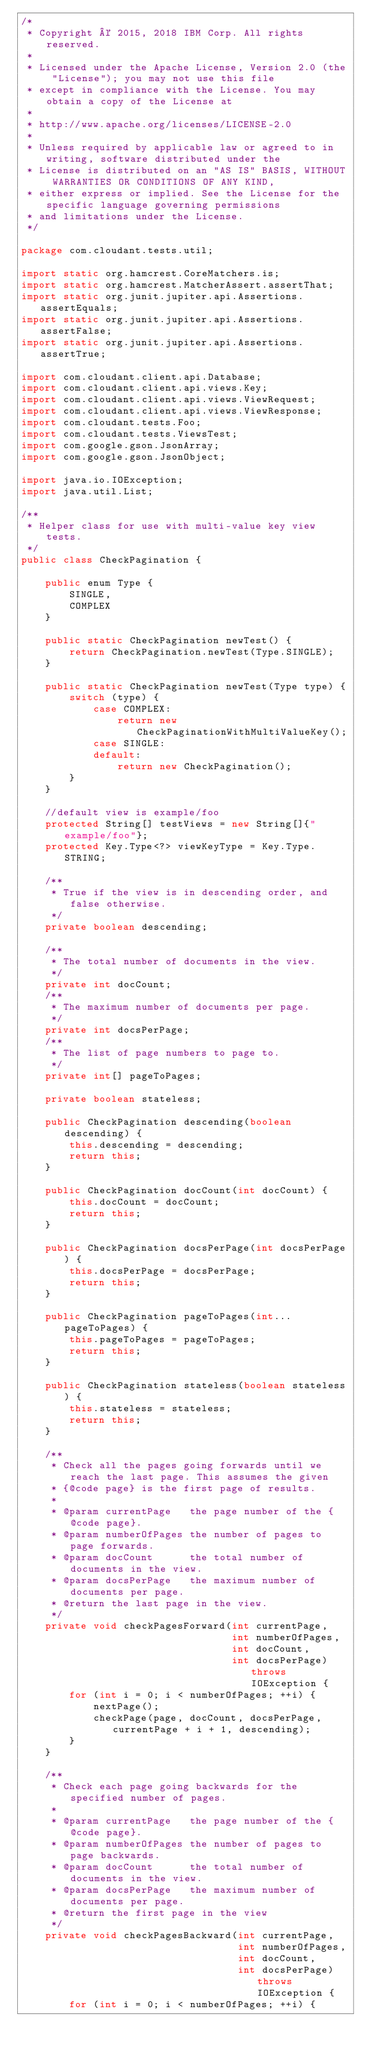<code> <loc_0><loc_0><loc_500><loc_500><_Java_>/*
 * Copyright © 2015, 2018 IBM Corp. All rights reserved.
 *
 * Licensed under the Apache License, Version 2.0 (the "License"); you may not use this file
 * except in compliance with the License. You may obtain a copy of the License at
 *
 * http://www.apache.org/licenses/LICENSE-2.0
 *
 * Unless required by applicable law or agreed to in writing, software distributed under the
 * License is distributed on an "AS IS" BASIS, WITHOUT WARRANTIES OR CONDITIONS OF ANY KIND,
 * either express or implied. See the License for the specific language governing permissions
 * and limitations under the License.
 */

package com.cloudant.tests.util;

import static org.hamcrest.CoreMatchers.is;
import static org.hamcrest.MatcherAssert.assertThat;
import static org.junit.jupiter.api.Assertions.assertEquals;
import static org.junit.jupiter.api.Assertions.assertFalse;
import static org.junit.jupiter.api.Assertions.assertTrue;

import com.cloudant.client.api.Database;
import com.cloudant.client.api.views.Key;
import com.cloudant.client.api.views.ViewRequest;
import com.cloudant.client.api.views.ViewResponse;
import com.cloudant.tests.Foo;
import com.cloudant.tests.ViewsTest;
import com.google.gson.JsonArray;
import com.google.gson.JsonObject;

import java.io.IOException;
import java.util.List;

/**
 * Helper class for use with multi-value key view tests.
 */
public class CheckPagination {

    public enum Type {
        SINGLE,
        COMPLEX
    }

    public static CheckPagination newTest() {
        return CheckPagination.newTest(Type.SINGLE);
    }

    public static CheckPagination newTest(Type type) {
        switch (type) {
            case COMPLEX:
                return new CheckPaginationWithMultiValueKey();
            case SINGLE:
            default:
                return new CheckPagination();
        }
    }

    //default view is example/foo
    protected String[] testViews = new String[]{"example/foo"};
    protected Key.Type<?> viewKeyType = Key.Type.STRING;

    /**
     * True if the view is in descending order, and false otherwise.
     */
    private boolean descending;

    /**
     * The total number of documents in the view.
     */
    private int docCount;
    /**
     * The maximum number of documents per page.
     */
    private int docsPerPage;
    /**
     * The list of page numbers to page to.
     */
    private int[] pageToPages;

    private boolean stateless;

    public CheckPagination descending(boolean descending) {
        this.descending = descending;
        return this;
    }

    public CheckPagination docCount(int docCount) {
        this.docCount = docCount;
        return this;
    }

    public CheckPagination docsPerPage(int docsPerPage) {
        this.docsPerPage = docsPerPage;
        return this;
    }

    public CheckPagination pageToPages(int... pageToPages) {
        this.pageToPages = pageToPages;
        return this;
    }

    public CheckPagination stateless(boolean stateless) {
        this.stateless = stateless;
        return this;
    }

    /**
     * Check all the pages going forwards until we reach the last page. This assumes the given
     * {@code page} is the first page of results.
     *
     * @param currentPage   the page number of the {@code page}.
     * @param numberOfPages the number of pages to page forwards.
     * @param docCount      the total number of documents in the view.
     * @param docsPerPage   the maximum number of documents per page.
     * @return the last page in the view.
     */
    private void checkPagesForward(int currentPage,
                                   int numberOfPages,
                                   int docCount,
                                   int docsPerPage) throws IOException {
        for (int i = 0; i < numberOfPages; ++i) {
            nextPage();
            checkPage(page, docCount, docsPerPage, currentPage + i + 1, descending);
        }
    }

    /**
     * Check each page going backwards for the specified number of pages.
     *
     * @param currentPage   the page number of the {@code page}.
     * @param numberOfPages the number of pages to page backwards.
     * @param docCount      the total number of documents in the view.
     * @param docsPerPage   the maximum number of documents per page.
     * @return the first page in the view
     */
    private void checkPagesBackward(int currentPage,
                                    int numberOfPages,
                                    int docCount,
                                    int docsPerPage) throws IOException {
        for (int i = 0; i < numberOfPages; ++i) {</code> 